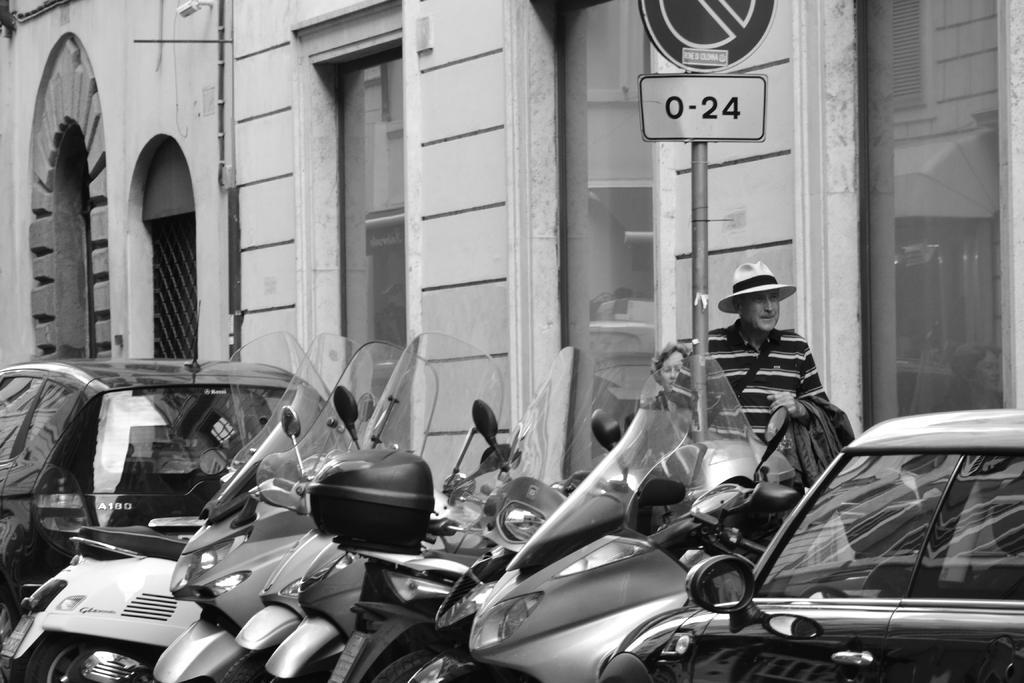In one or two sentences, can you explain what this image depicts? In the foreground of this black and white image, there are few motor bikes, cars and a sign board. Behind it, there are two people and a building with glass windows and arches. 